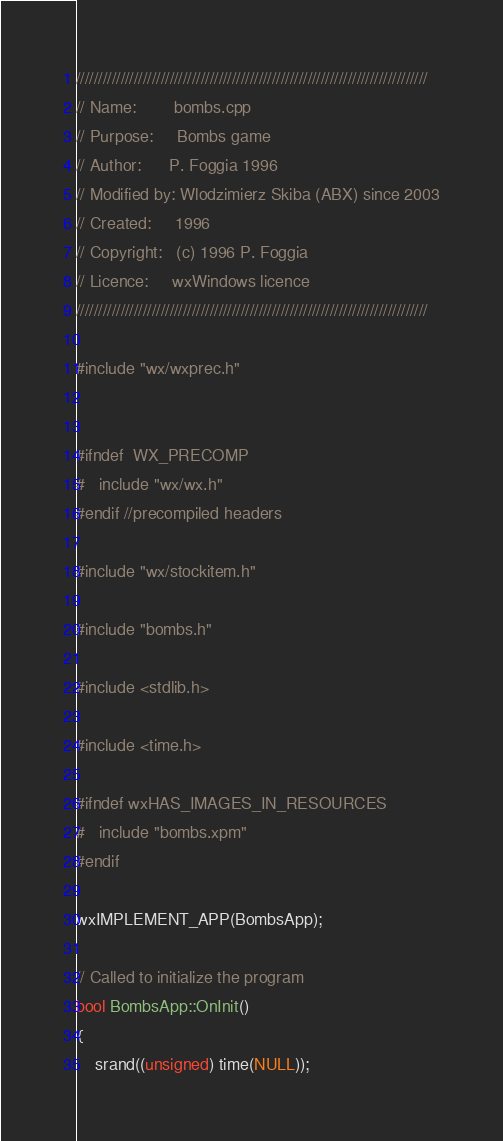Convert code to text. <code><loc_0><loc_0><loc_500><loc_500><_C++_>///////////////////////////////////////////////////////////////////////////////
// Name:        bombs.cpp
// Purpose:     Bombs game
// Author:      P. Foggia 1996
// Modified by: Wlodzimierz Skiba (ABX) since 2003
// Created:     1996
// Copyright:   (c) 1996 P. Foggia
// Licence:     wxWindows licence
///////////////////////////////////////////////////////////////////////////////

#include "wx/wxprec.h"


#ifndef  WX_PRECOMP
#   include "wx/wx.h"
#endif //precompiled headers

#include "wx/stockitem.h"

#include "bombs.h"

#include <stdlib.h>

#include <time.h>

#ifndef wxHAS_IMAGES_IN_RESOURCES
#   include "bombs.xpm"
#endif

wxIMPLEMENT_APP(BombsApp);

// Called to initialize the program
bool BombsApp::OnInit()
{
    srand((unsigned) time(NULL));
</code> 